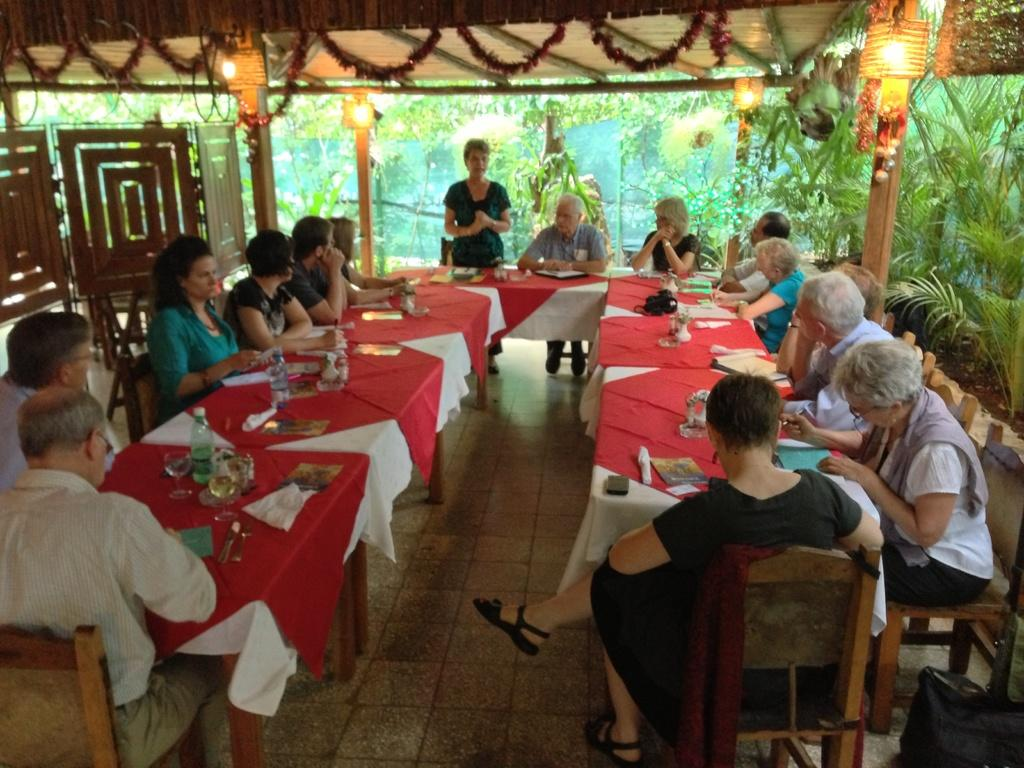What are the people in the image doing? The people in the image are sitting in chairs. What is in front of the group of people? There is a table in front of the group of people. What can be seen on the table? There are objects on the table. What is the woman wearing standing in front of the group of people? The woman is wearing a green dress. What type of dinosaurs are present in the image? There are no dinosaurs present in the image. What is the cause of the fight between the people in the image? There is no fight depicted in the image; the people are sitting calmly in chairs. 